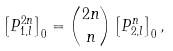Convert formula to latex. <formula><loc_0><loc_0><loc_500><loc_500>\left [ P _ { 1 , l } ^ { 2 n } \right ] _ { 0 } = \binom { 2 n } { n } \left [ P _ { 2 , l } ^ { n } \right ] _ { 0 } ,</formula> 